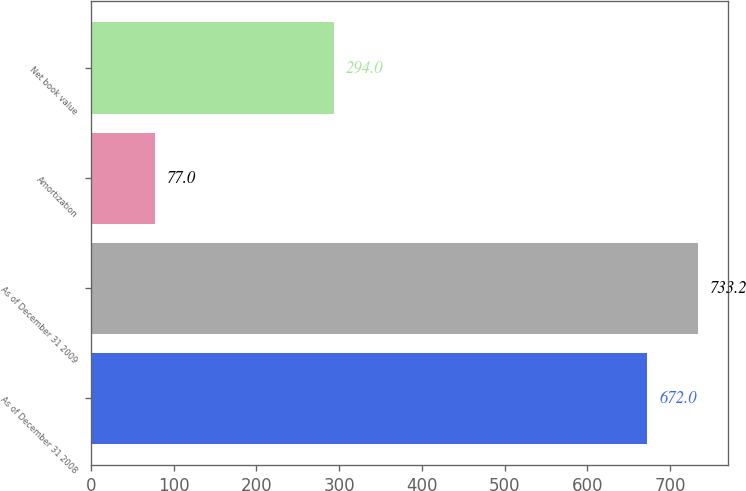Convert chart. <chart><loc_0><loc_0><loc_500><loc_500><bar_chart><fcel>As of December 31 2008<fcel>As of December 31 2009<fcel>Amortization<fcel>Net book value<nl><fcel>672<fcel>733.2<fcel>77<fcel>294<nl></chart> 